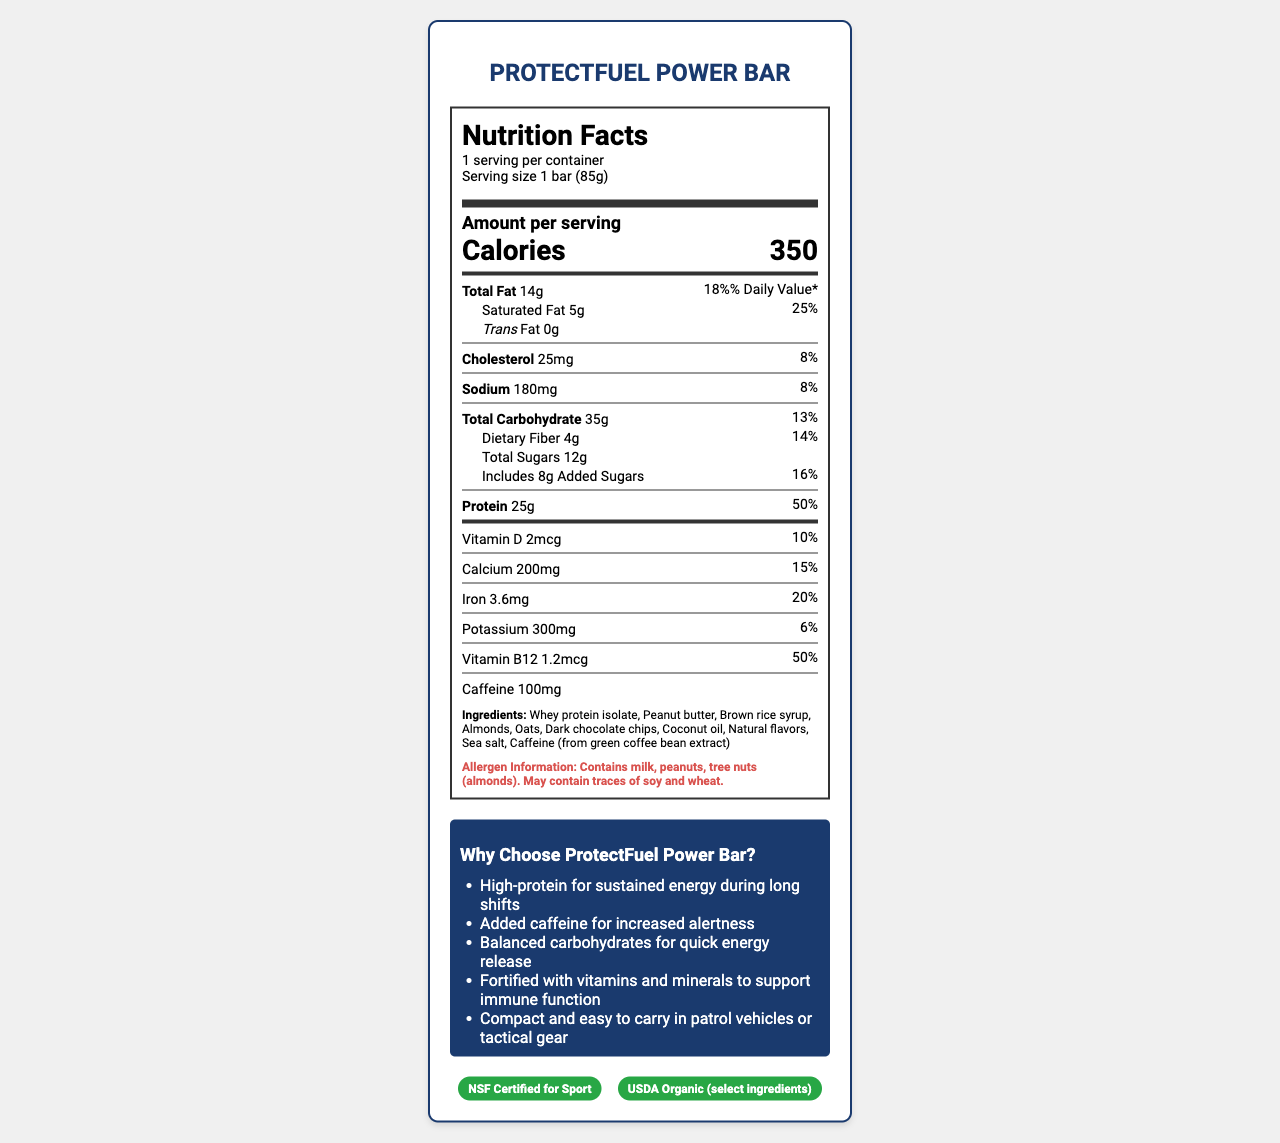what is the serving size of the ProtectFuel Power Bar? The serving size is explicitly mentioned as 1 bar (85g) in the document.
Answer: 1 bar (85g) how many calories does one bar of ProtectFuel Power Bar contain? The calorie count is stated as 350 in the amount per serving section.
Answer: 350 what is the total amount of fat in the ProtectFuel Power Bar? The total fat amount is listed as 14g.
Answer: 14g what percentage of the daily value for protein does the ProtectFuel Power Bar provide? The daily value percentage for protein is indicated as 50%.
Answer: 50% what is the amount of caffeine in one serving of the ProtectFuel Power Bar? The amount of caffeine per serving is listed as 100mg.
Answer: 100mg what are the allergens present in the ProtectFuel Power Bar? The allergen information section lists milk, peanuts, and tree nuts (almonds) and warns that it may contain traces of soy and wheat.
Answer: Contains milk, peanuts, tree nuts (almonds). May contain traces of soy and wheat. how long is the shelf life of the ProtectFuel Power Bar? The shelf life is stated as 12 months in the marketing claims section.
Answer: 12 months when stored in a cool, dry place what are the top three ingredients in the ProtectFuel Power Bar? The top three ingredients listed are whey protein isolate, peanut butter, and brown rice syrup.
Answer: Whey protein isolate, Peanut butter, Brown rice syrup which vitamin has a daily value percentage of 50% in the ProtectFuel Power Bar? A. Vitamin D B. Calcium C. Iron D. Vitamin B12 Vitamin B12 has a daily value percentage of 50%, as indicated in the nutrition facts section.
Answer: D how much dietary fiber does the ProtectFuel Power Bar contain? The dietary fiber content is specified as 4g.
Answer: 4g who is the manufacturer of the ProtectFuel Power Bar? The manufacturer is stated as TactiNutrition Labs, Inc.
Answer: TactiNutrition Labs, Inc. is the ProtectFuel Power Bar NSF Certified for Sport? The certifications section lists NSF Certified for Sport.
Answer: Yes what is one of the benefits of the ProtectFuel Power Bar mentioned in the marketing claims? This is one of the benefits listed in the marketing claims section.
Answer: High-protein for sustained energy during long shifts what are two types of nuts included in the ProtectFuel Power Bar's ingredients? A. Walnuts and Cashews B. Peanuts and Almonds C. Hazelnuts and Macadamia Nuts Peanuts and almonds are listed in the ingredients section.
Answer: B is there any added sugars in the ProtectFuel Power Bar? The document states that there are 8g of added sugars.
Answer: Yes what is the total carbohydrate content in the ProtectFuel Power Bar? The total carbohydrate content is listed as 35g.
Answer: 35g how is the daily value percentage for vitamin D presented in the document? The daily value percentage for vitamin D is specified as 10%.
Answer: 10% is the amount of trans fat specified for the ProtectFuel Power Bar? The document states that the trans fat amount is 0g.
Answer: Yes summarize the main idea of the ProtectFuel Power Bar's nutrition label. The document contains detailed nutrition information, marketing claims, ingredients, allergen information, and certifications which collectively indicate that the product is a nutritious, energy-boosting protein bar tailored for law enforcement officers.
Answer: The ProtectFuel Power Bar is a high-protein, high-energy snack with added caffeine, designed specifically for law enforcement personnel. It provides essential vitamins and minerals, and is convenient to carry. The bar contains allergens like milk, peanuts, and tree nuts, and is certified by NSF for Sport and includes USDA Organic ingredients. where is the protein source derived from in the ProtectFuel Power Bar? The document lists the ingredient as whey protein isolate but does not specify the source of the whey protein isolate.
Answer: Cannot be determined how many milligrams of sodium does the ProtectFuel Power Bar contain? The sodium content is listed as 180mg.
Answer: 180mg 